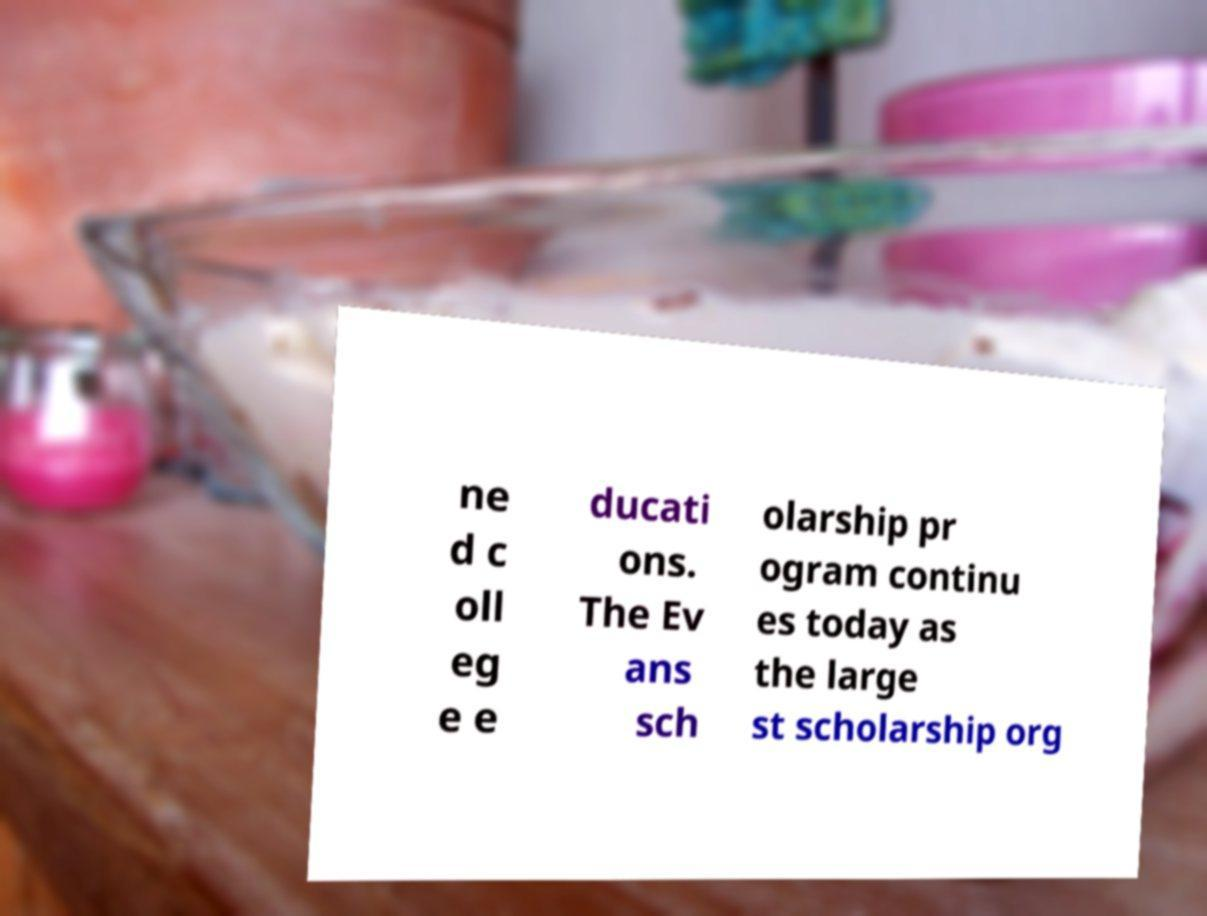What messages or text are displayed in this image? I need them in a readable, typed format. ne d c oll eg e e ducati ons. The Ev ans sch olarship pr ogram continu es today as the large st scholarship org 